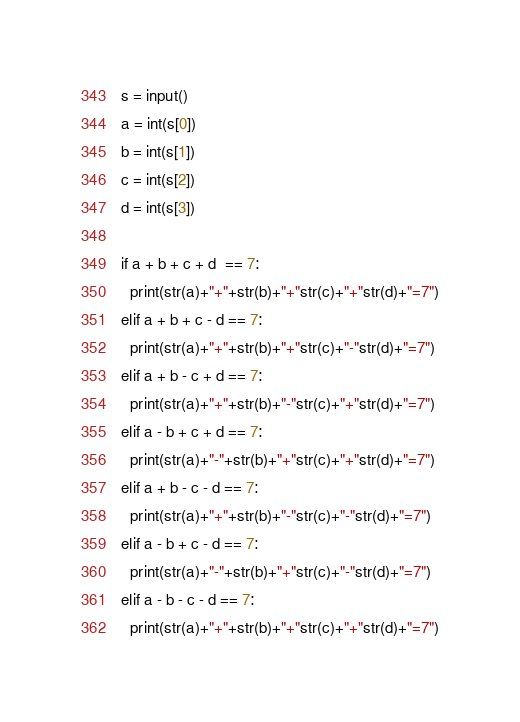Convert code to text. <code><loc_0><loc_0><loc_500><loc_500><_Python_>s = input()
a = int(s[0])
b = int(s[1])
c = int(s[2])
d = int(s[3])

if a + b + c + d  == 7:
  print(str(a)+"+"+str(b)+"+"str(c)+"+"str(d)+"=7")
elif a + b + c - d == 7:
  print(str(a)+"+"+str(b)+"+"str(c)+"-"str(d)+"=7")
elif a + b - c + d == 7:
  print(str(a)+"+"+str(b)+"-"str(c)+"+"str(d)+"=7")
elif a - b + c + d == 7:
  print(str(a)+"-"+str(b)+"+"str(c)+"+"str(d)+"=7")
elif a + b - c - d == 7:
  print(str(a)+"+"+str(b)+"-"str(c)+"-"str(d)+"=7")
elif a - b + c - d == 7:
  print(str(a)+"-"+str(b)+"+"str(c)+"-"str(d)+"=7")
elif a - b - c - d == 7:
  print(str(a)+"+"+str(b)+"+"str(c)+"+"str(d)+"=7")</code> 